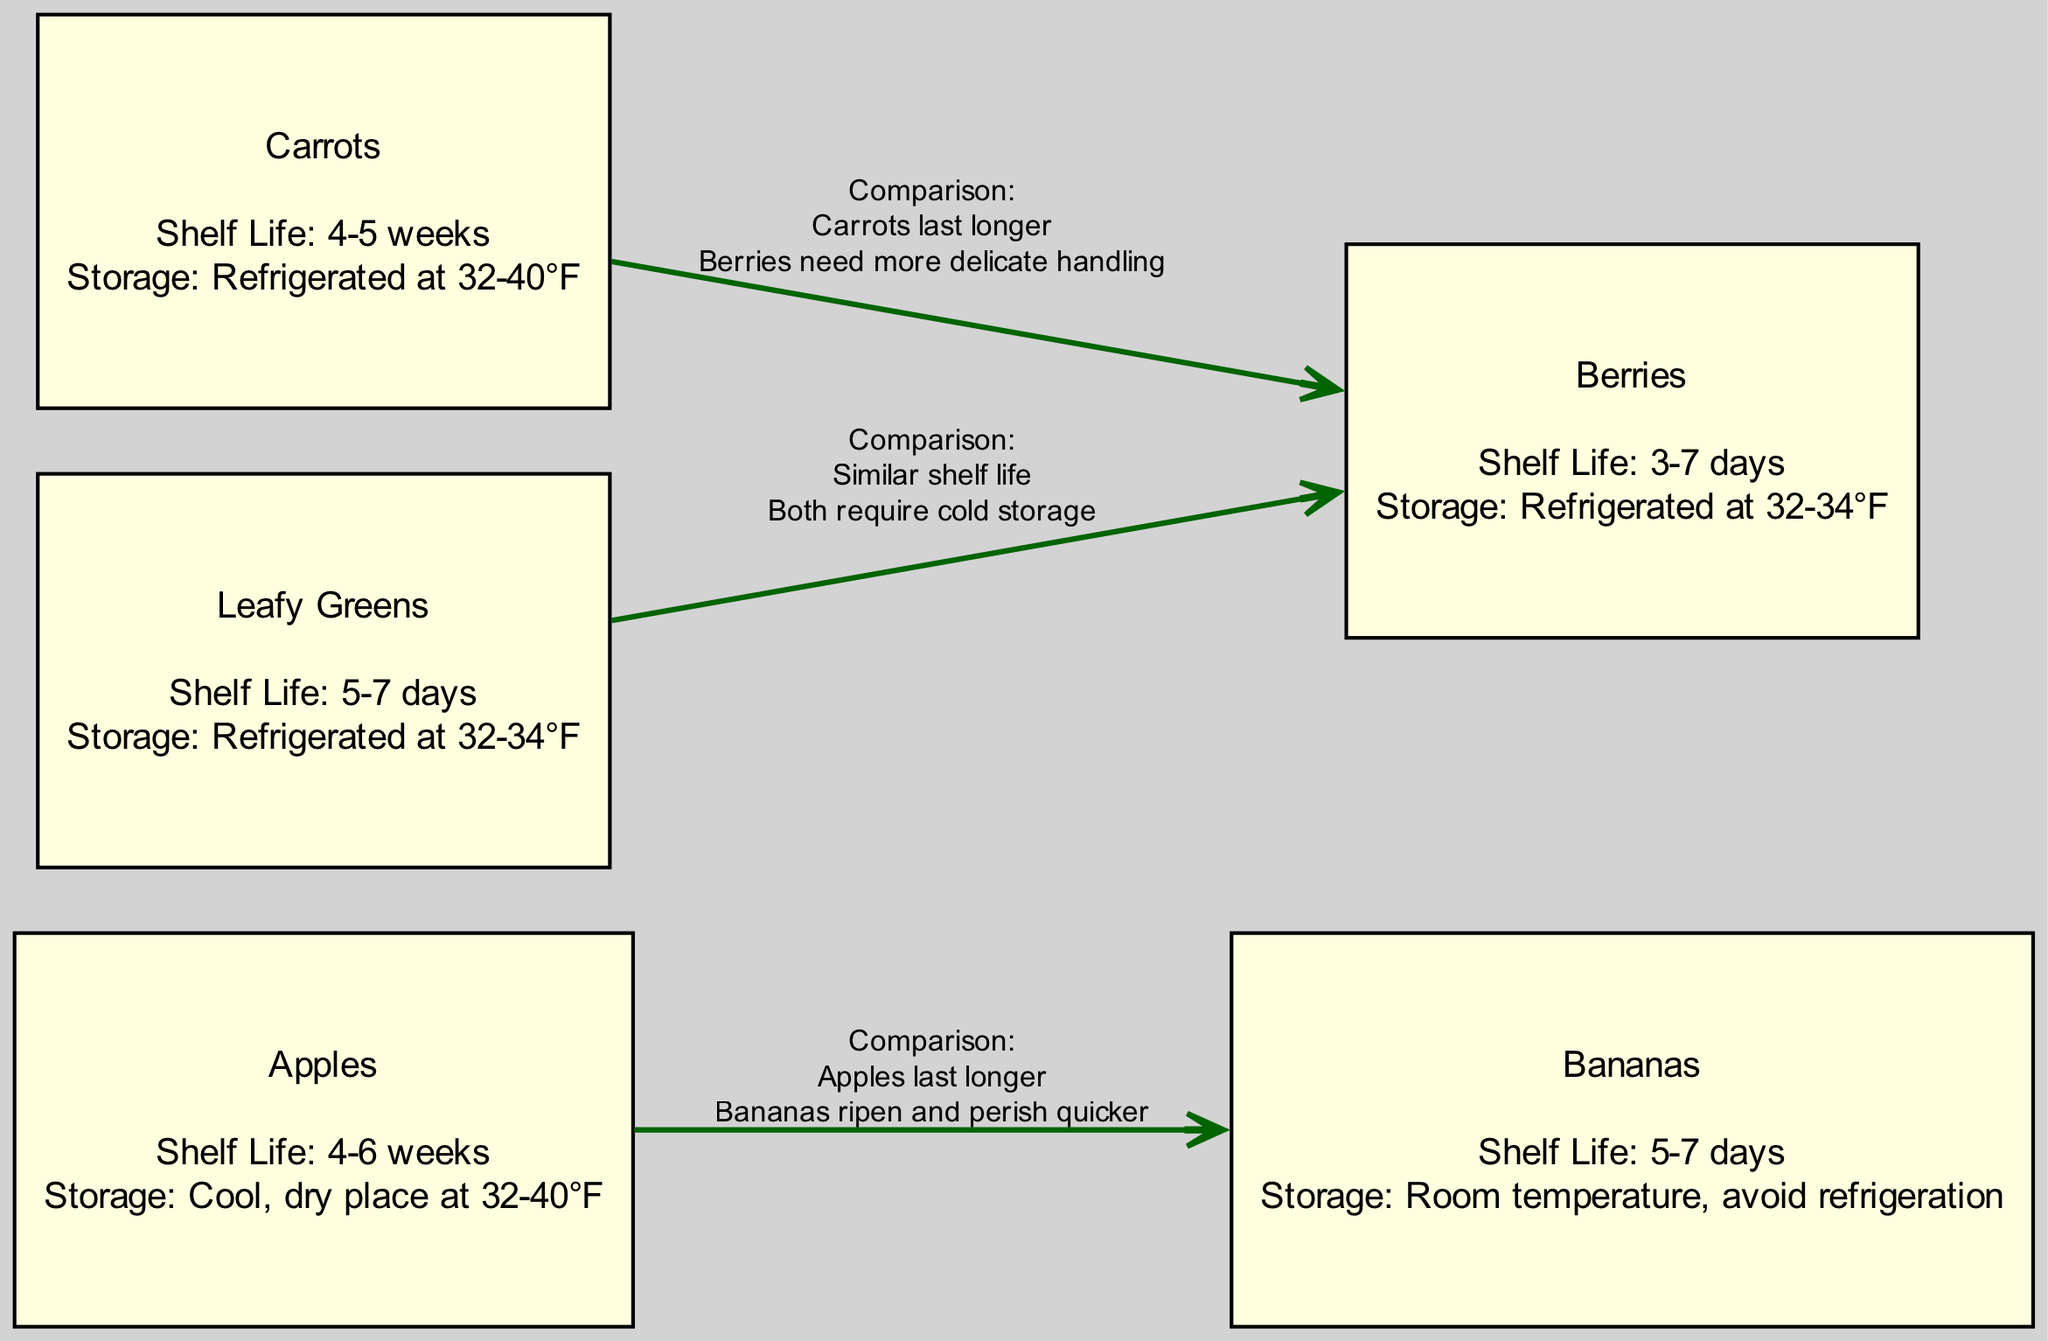What is the average shelf life of apples? According to the diagram, the average shelf life of apples is noted as 4-6 weeks.
Answer: 4-6 weeks What are the optimal storage conditions for bananas? The diagram specifies that bananas should be stored at room temperature and that refrigeration should be avoided.
Answer: Room temperature, avoid refrigeration Which produce lasts longer, carrots or berries? The diagram indicates a comparison between carrots and berries, stating that carrots last longer.
Answer: Carrots How many types of produce are compared in the diagram? By counting the nodes listed in the diagram, we find that there are five types of produce compared: apples, bananas, carrots, berries, and leafy greens.
Answer: 5 What is the shelf life range for leafy greens and berries? The diagram states that leafy greens have an average shelf life of 5-7 days and berries have a range of 3-7 days, so both fall within the same range of shelf life.
Answer: Similar shelf life Which two produce types require refrigeration for optimal storage? The diagram shows that both carrots and berries require refrigeration at temperatures between 32-40°F for carrots and 32-34°F for berries.
Answer: Carrots and Berries What special condition is noted for the storage of bananas? The diagram states that bananas should be stored at room temperature, indicating that they should not be refrigerated, which is a special condition they have compared to other produce.
Answer: Avoid refrigeration Which types of produce need delicate handling based on the comparison with carrots? The diagram illustrates that berries require more delicate handling when compared to carrots.
Answer: Berries What is the average shelf life of carrots? The average shelf life of carrots as per the diagram is specified to be 4-5 weeks.
Answer: 4-5 weeks 